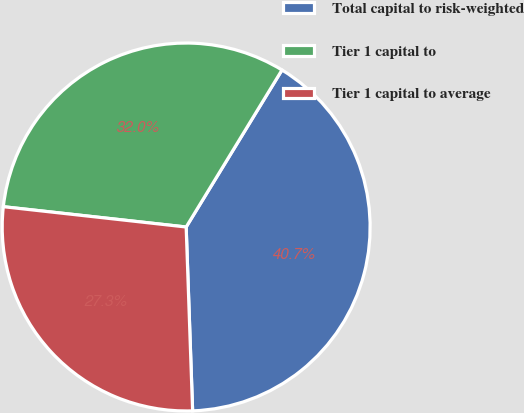Convert chart to OTSL. <chart><loc_0><loc_0><loc_500><loc_500><pie_chart><fcel>Total capital to risk-weighted<fcel>Tier 1 capital to<fcel>Tier 1 capital to average<nl><fcel>40.72%<fcel>31.96%<fcel>27.32%<nl></chart> 